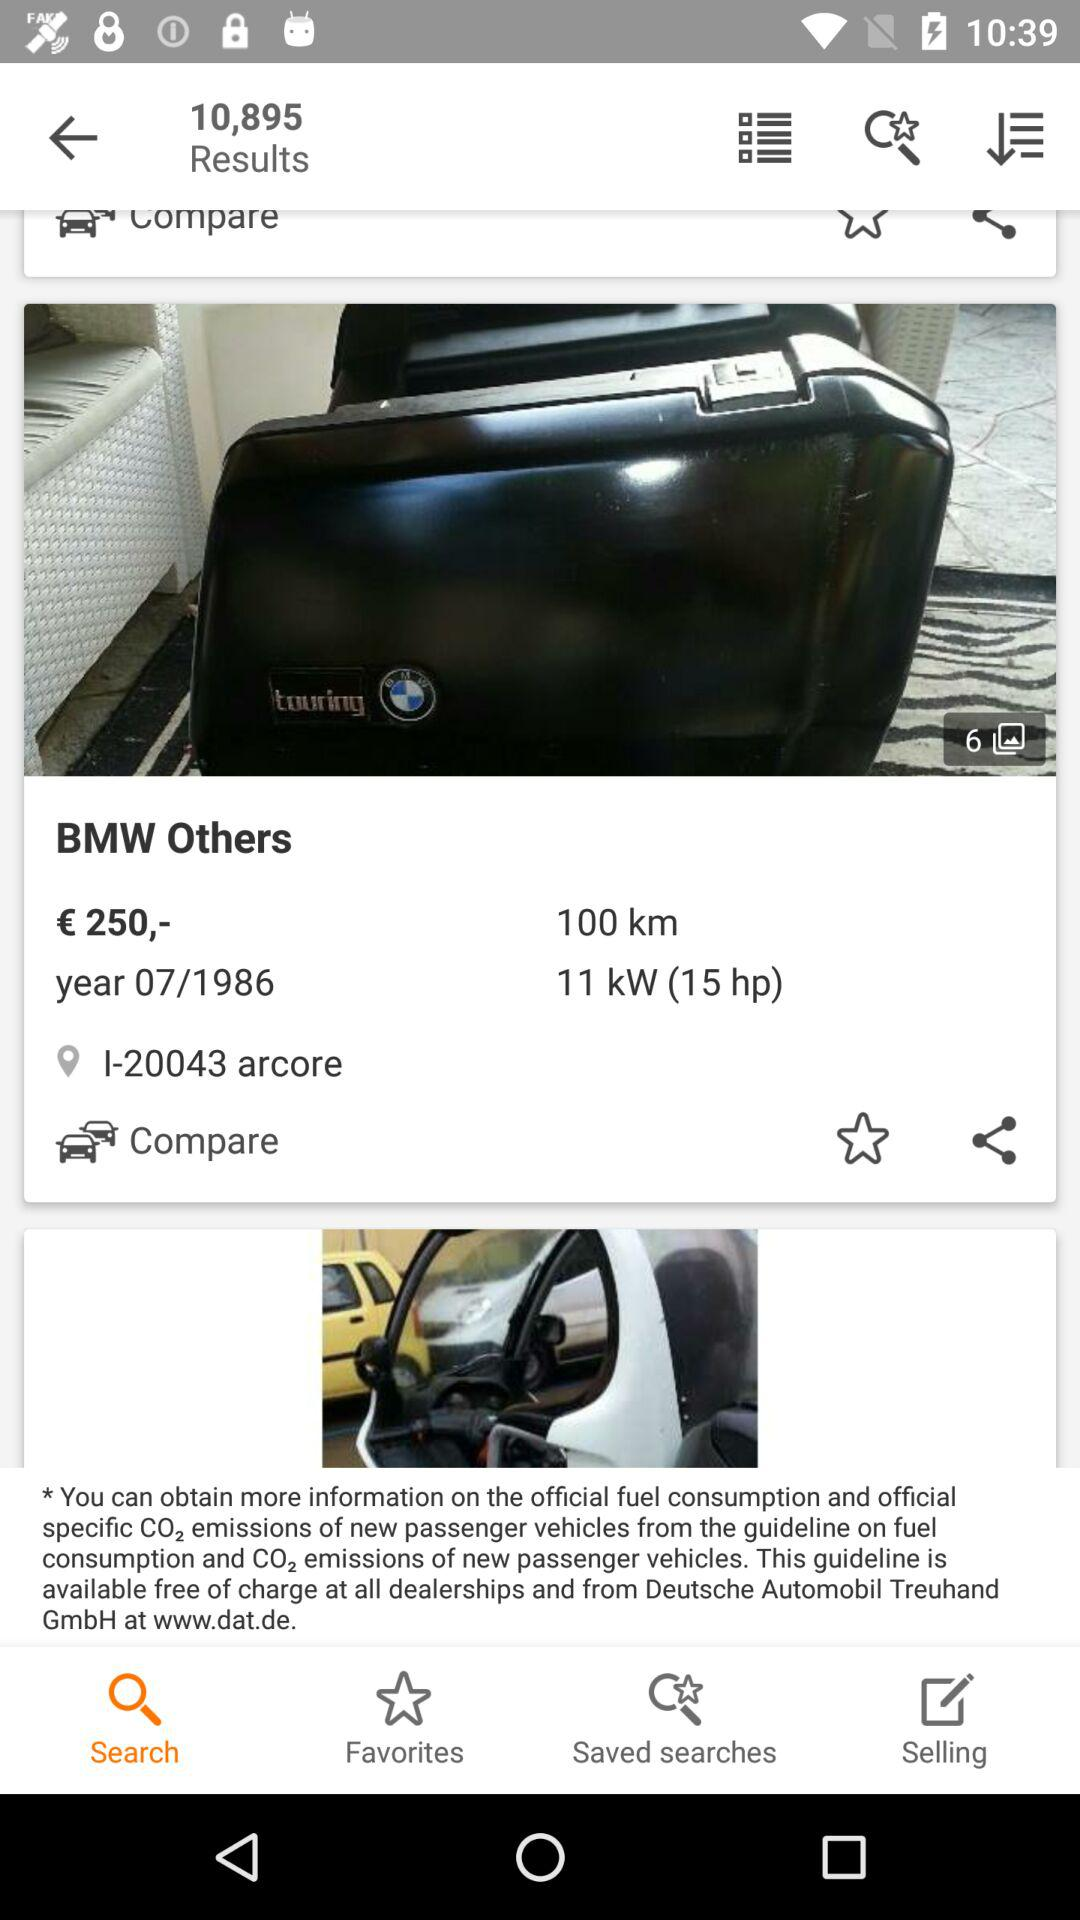What is the average fuel consumption by BMW others?
When the provided information is insufficient, respond with <no answer>. <no answer> 